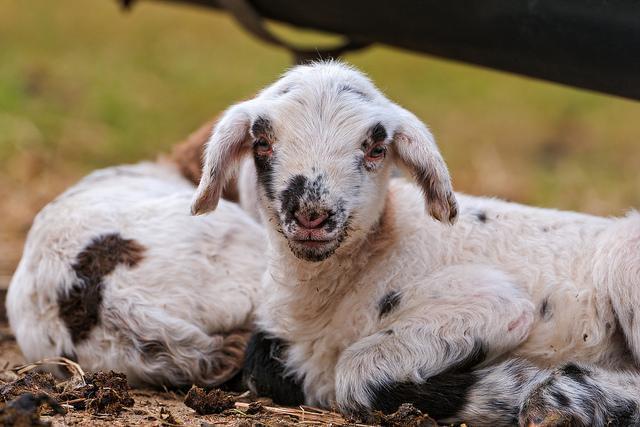How many sheep are there?
Give a very brief answer. 2. How many different colored cows do you see?
Give a very brief answer. 0. 